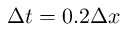Convert formula to latex. <formula><loc_0><loc_0><loc_500><loc_500>\Delta t = 0 . 2 \Delta x</formula> 